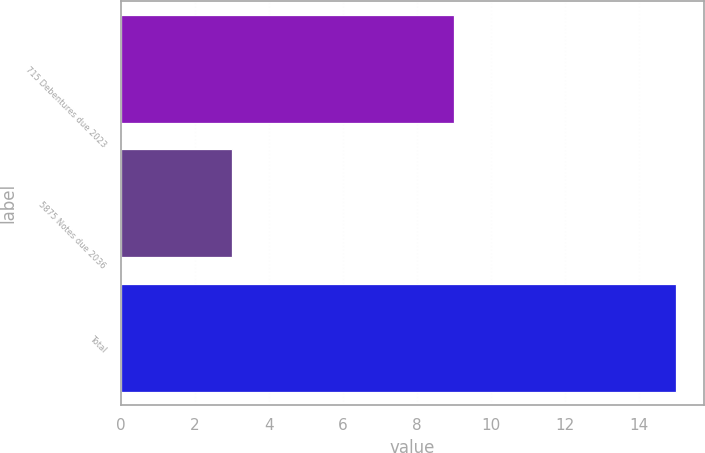<chart> <loc_0><loc_0><loc_500><loc_500><bar_chart><fcel>715 Debentures due 2023<fcel>5875 Notes due 2036<fcel>Total<nl><fcel>9<fcel>3<fcel>15<nl></chart> 